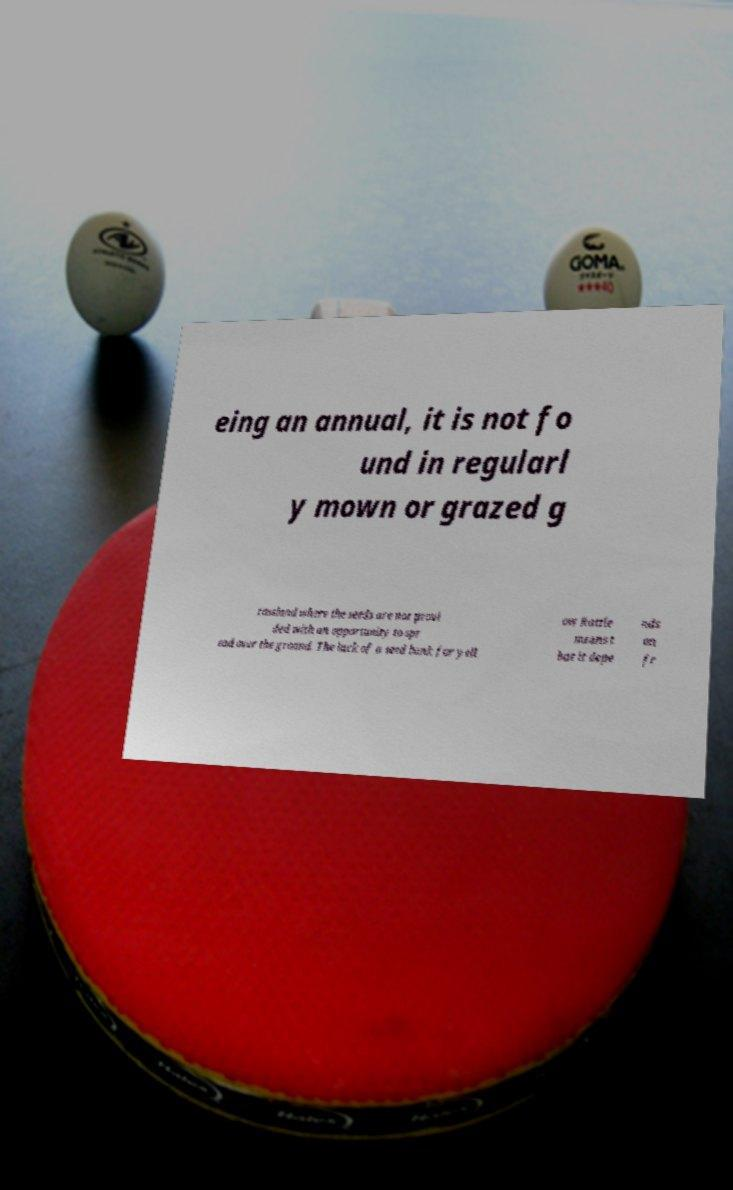Could you assist in decoding the text presented in this image and type it out clearly? eing an annual, it is not fo und in regularl y mown or grazed g rassland where the seeds are not provi ded with an opportunity to spr ead over the ground. The lack of a seed bank for yell ow Rattle means t hat it depe nds on fr 